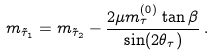Convert formula to latex. <formula><loc_0><loc_0><loc_500><loc_500>m _ { \tilde { \tau } _ { 1 } } = m _ { \tilde { \tau } _ { 2 } } - \frac { 2 \mu m _ { \tau } ^ { ( 0 ) } \tan \beta } { \sin ( 2 \theta _ { \tau } ) } \, .</formula> 